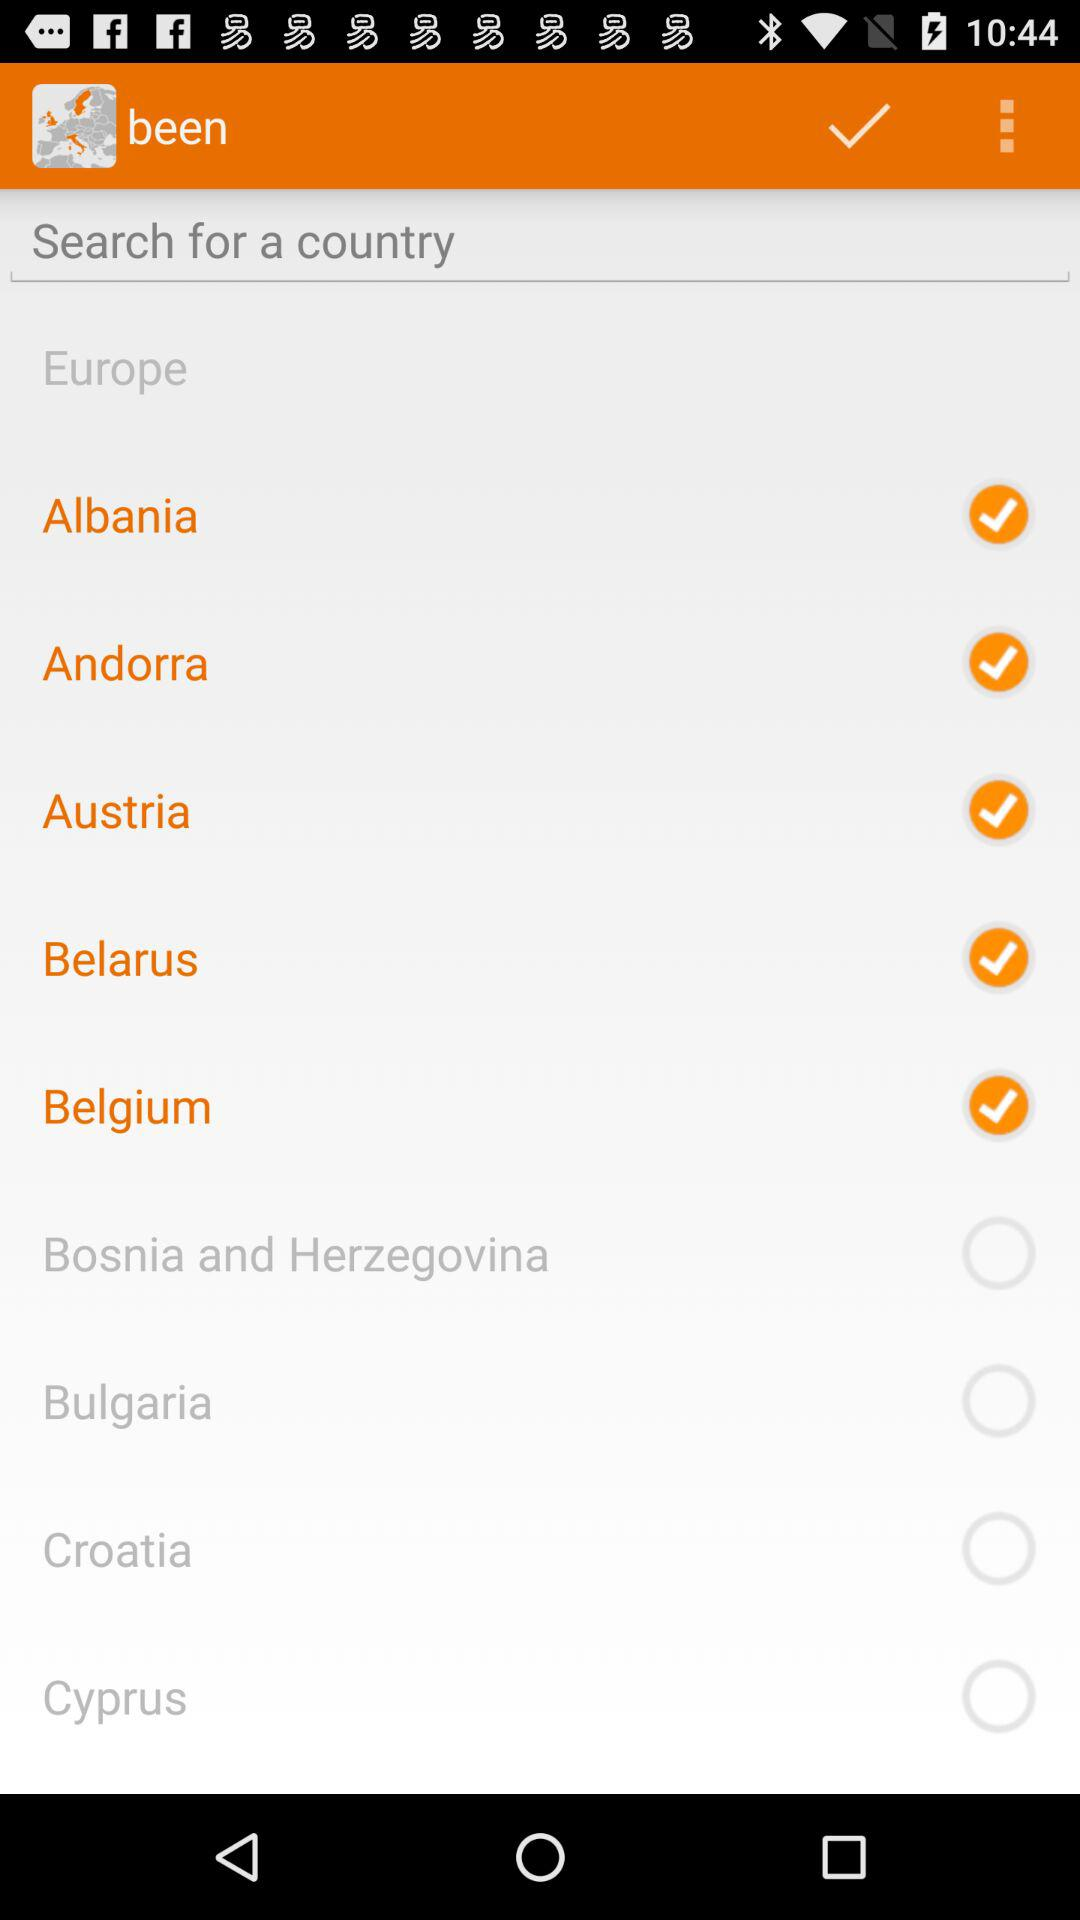What is the name of the application? The name of the application is "been". 